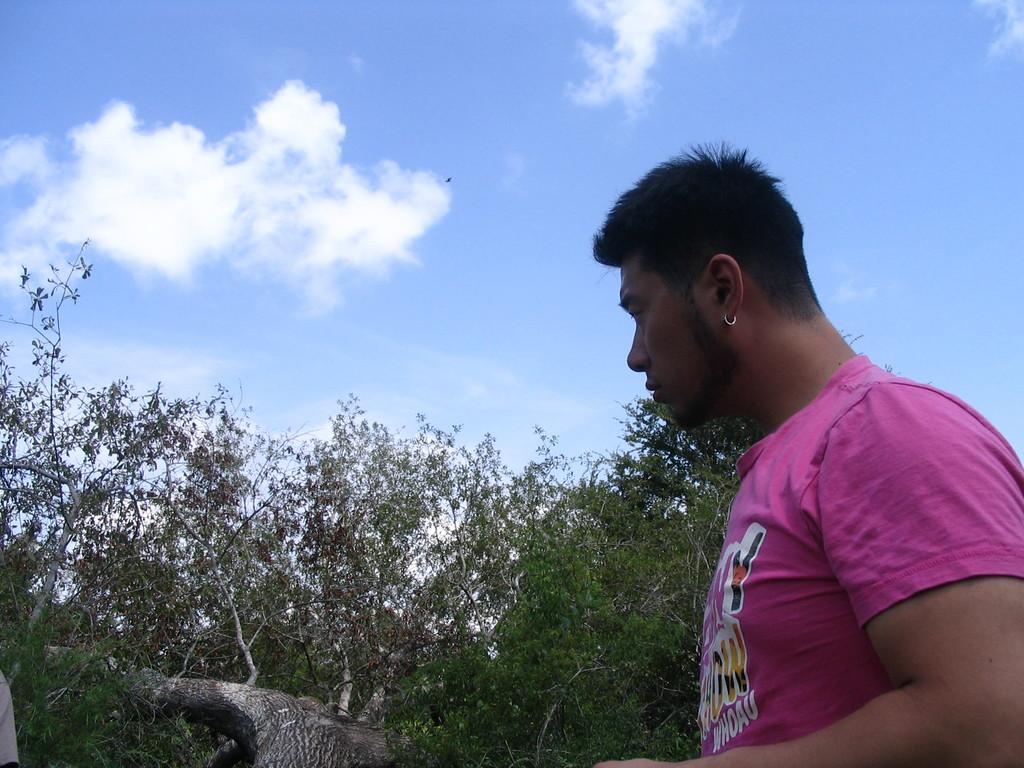What is present in the image? There is a person in the image. What is the person wearing? The person is wearing a pink shirt. What can be seen in the background of the image? There are trees and the sky visible in the background of the image. What color are the trees? The trees are green. How would you describe the sky in the image? The sky has both white and blue colors. Can you see a robin flying over the ocean in the image? There is no robin or ocean present in the image. 